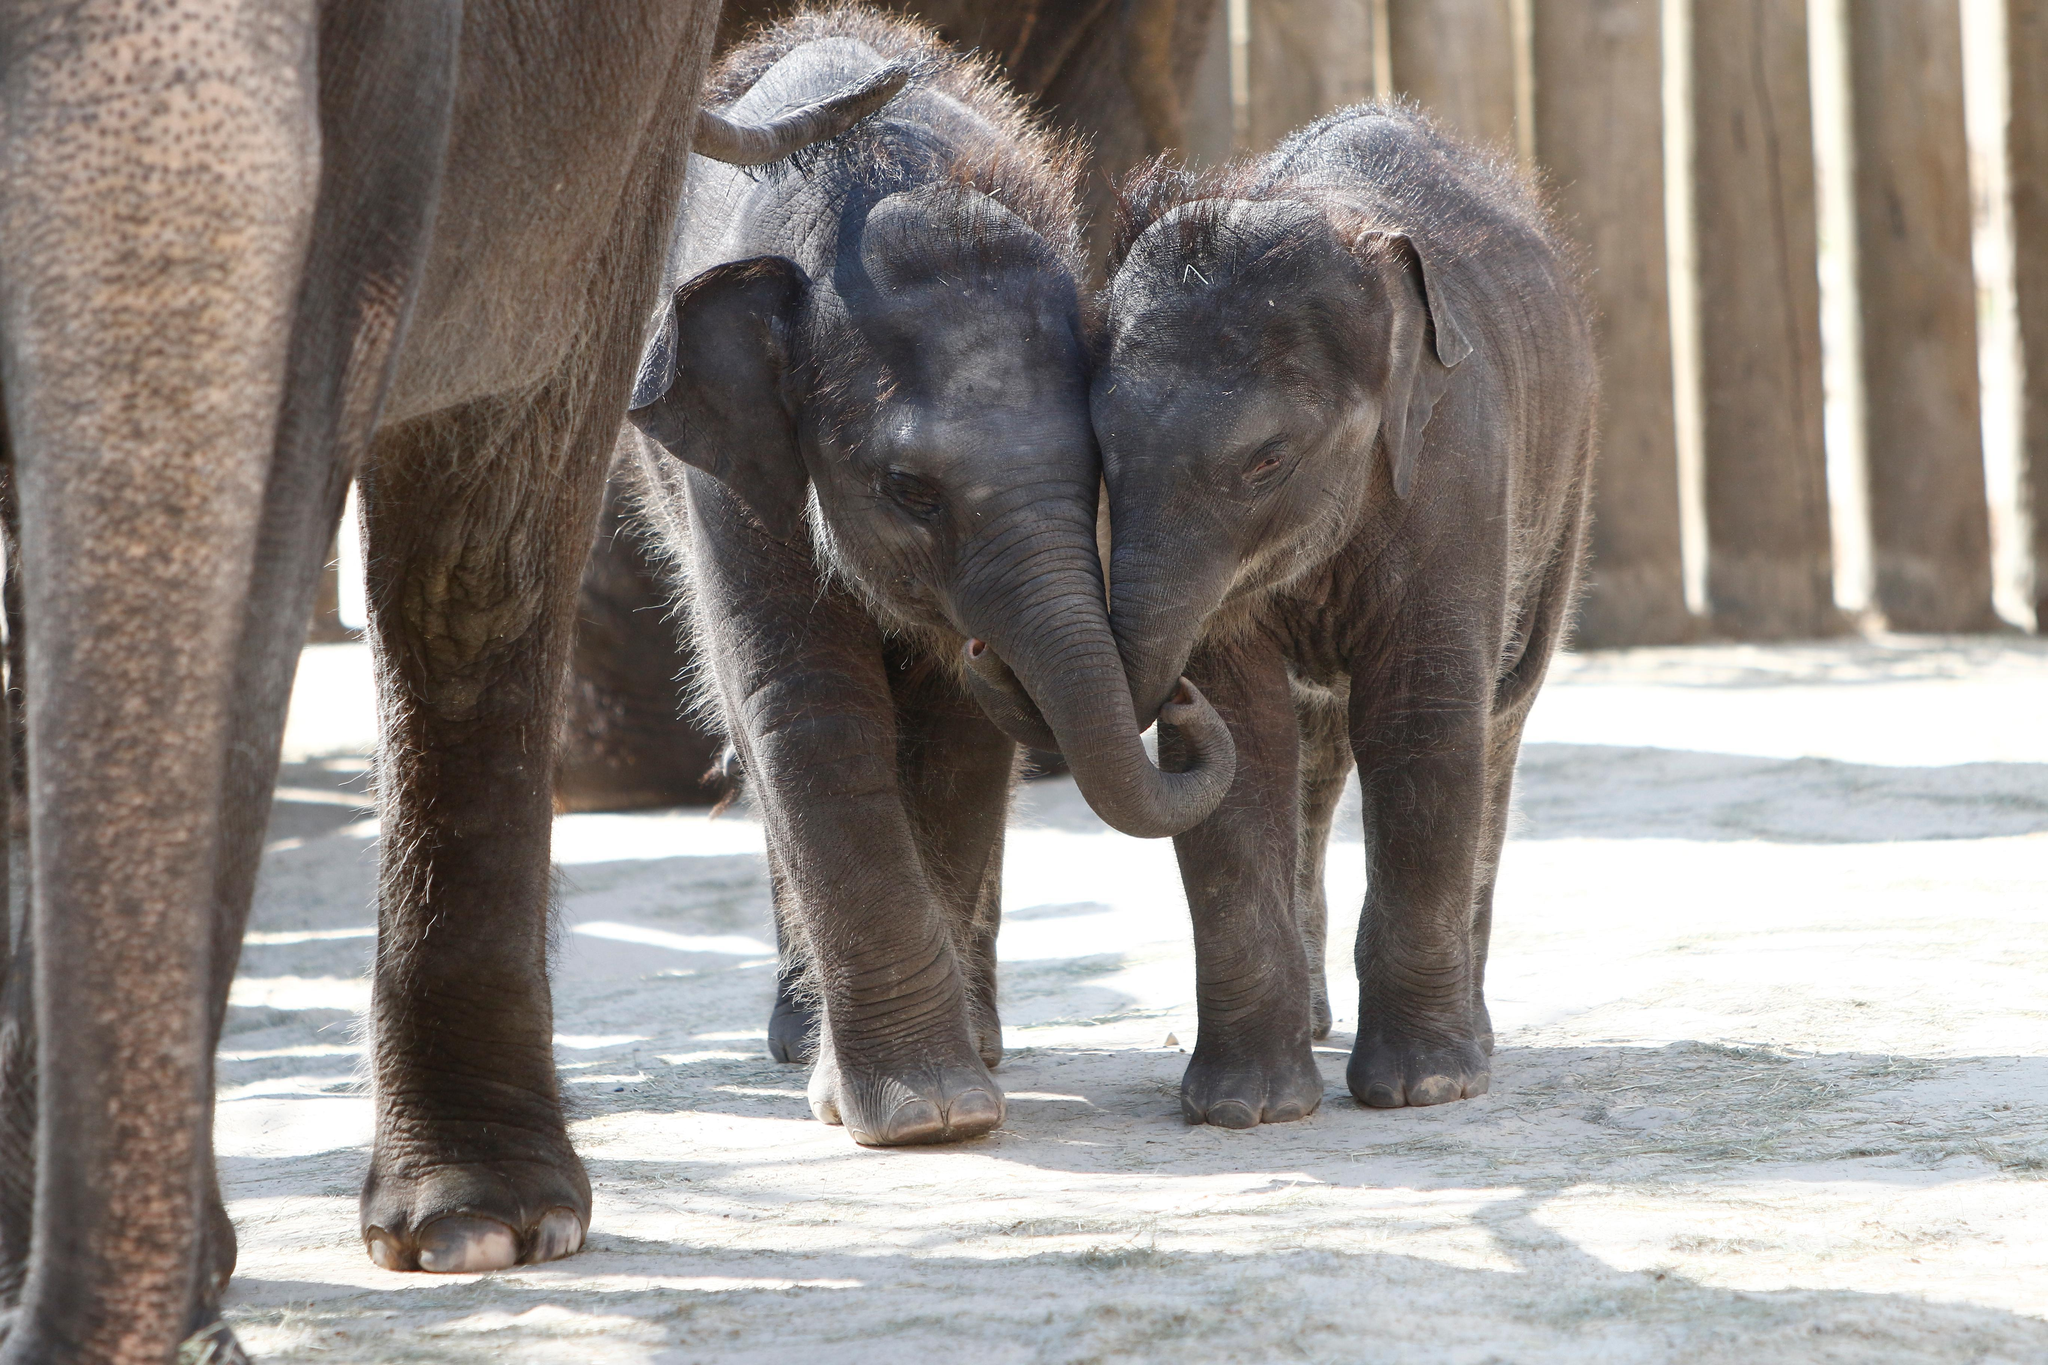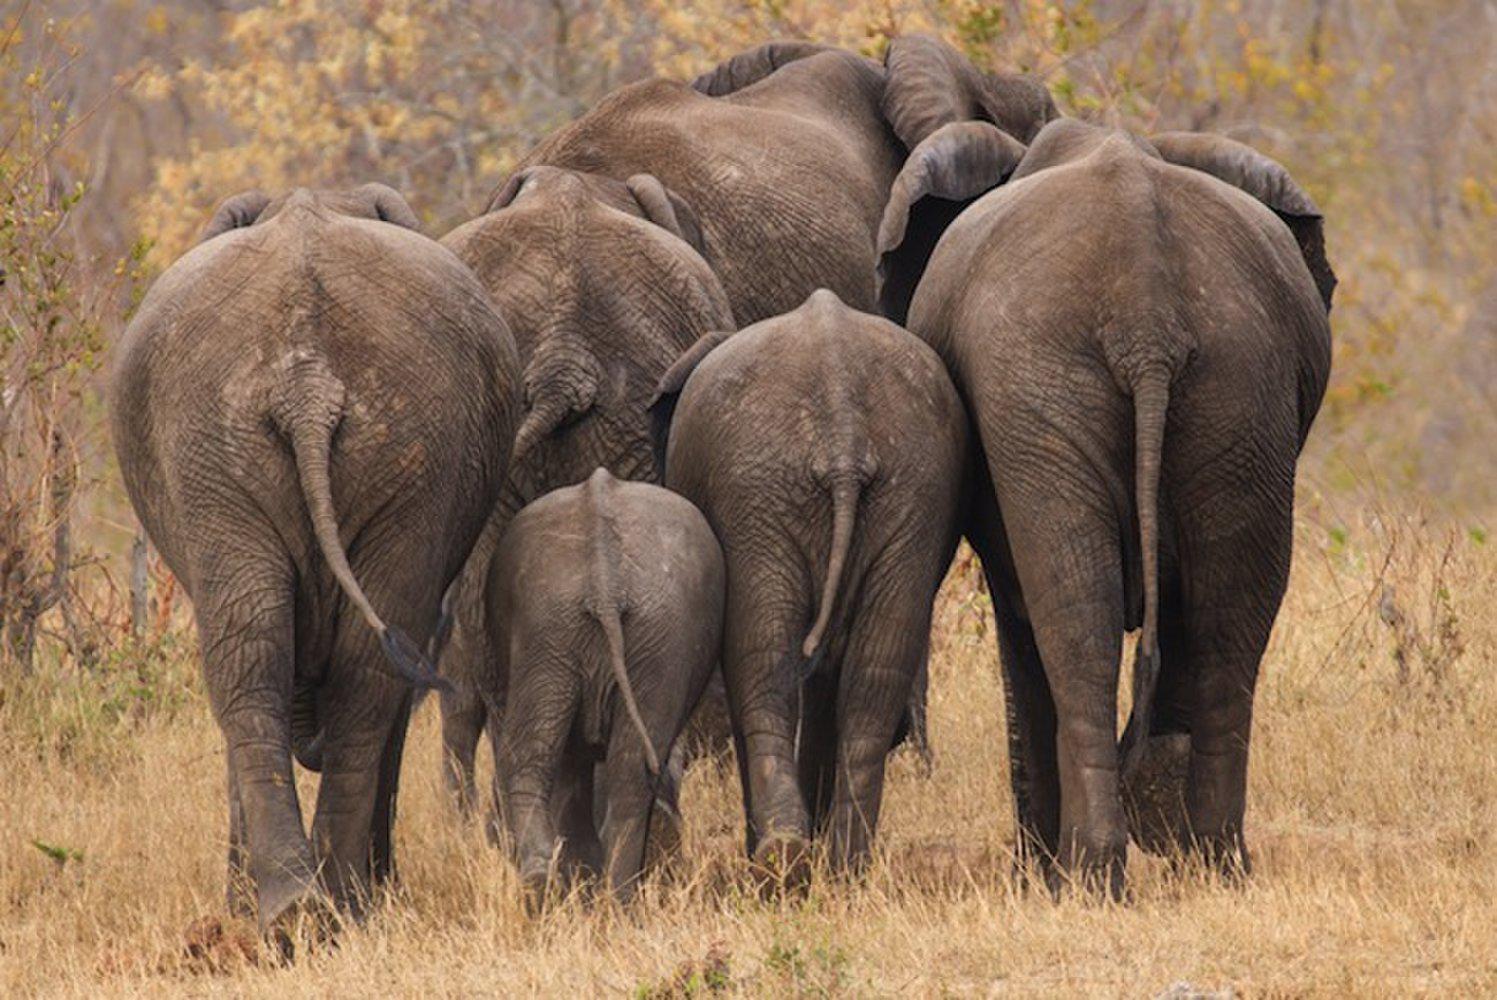The first image is the image on the left, the second image is the image on the right. Assess this claim about the two images: "Right image shows a forward facing baby elephant to the right of an adult elephant's legs.". Correct or not? Answer yes or no. No. The first image is the image on the left, the second image is the image on the right. For the images shown, is this caption "All images show at least one young elephant." true? Answer yes or no. Yes. 